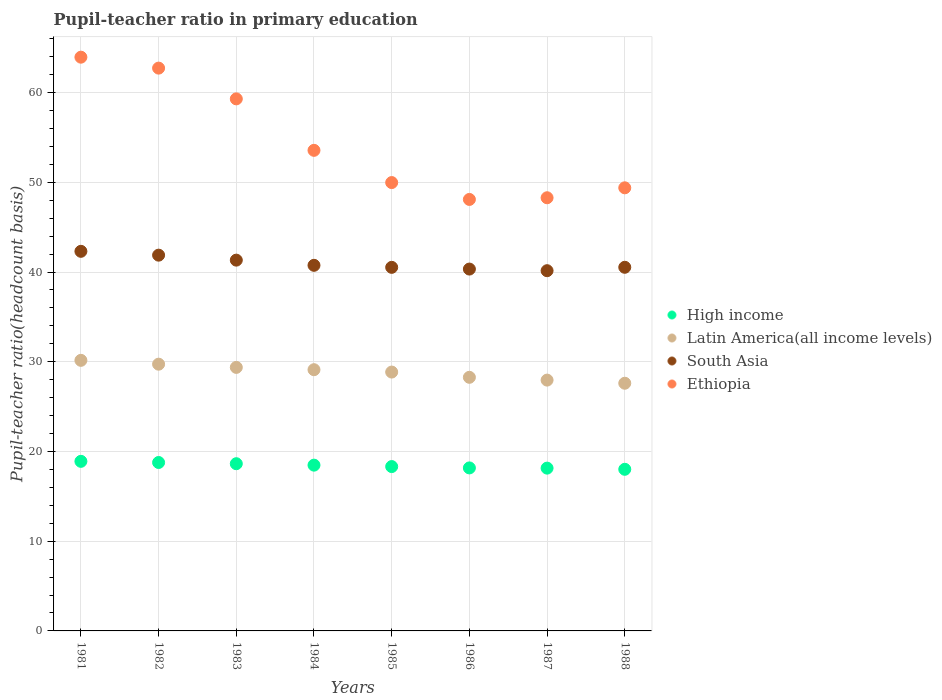How many different coloured dotlines are there?
Give a very brief answer. 4. Is the number of dotlines equal to the number of legend labels?
Your answer should be compact. Yes. What is the pupil-teacher ratio in primary education in Latin America(all income levels) in 1981?
Make the answer very short. 30.16. Across all years, what is the maximum pupil-teacher ratio in primary education in South Asia?
Offer a very short reply. 42.31. Across all years, what is the minimum pupil-teacher ratio in primary education in South Asia?
Make the answer very short. 40.15. In which year was the pupil-teacher ratio in primary education in High income minimum?
Offer a terse response. 1988. What is the total pupil-teacher ratio in primary education in High income in the graph?
Your answer should be compact. 147.42. What is the difference between the pupil-teacher ratio in primary education in South Asia in 1981 and that in 1985?
Provide a short and direct response. 1.79. What is the difference between the pupil-teacher ratio in primary education in South Asia in 1988 and the pupil-teacher ratio in primary education in Latin America(all income levels) in 1981?
Your answer should be very brief. 10.37. What is the average pupil-teacher ratio in primary education in Ethiopia per year?
Your answer should be very brief. 54.41. In the year 1987, what is the difference between the pupil-teacher ratio in primary education in Ethiopia and pupil-teacher ratio in primary education in South Asia?
Your response must be concise. 8.13. In how many years, is the pupil-teacher ratio in primary education in Ethiopia greater than 46?
Your answer should be very brief. 8. What is the ratio of the pupil-teacher ratio in primary education in South Asia in 1982 to that in 1987?
Make the answer very short. 1.04. Is the pupil-teacher ratio in primary education in Ethiopia in 1981 less than that in 1984?
Offer a very short reply. No. Is the difference between the pupil-teacher ratio in primary education in Ethiopia in 1982 and 1987 greater than the difference between the pupil-teacher ratio in primary education in South Asia in 1982 and 1987?
Your response must be concise. Yes. What is the difference between the highest and the second highest pupil-teacher ratio in primary education in Ethiopia?
Provide a succinct answer. 1.22. What is the difference between the highest and the lowest pupil-teacher ratio in primary education in High income?
Your answer should be compact. 0.89. Is the sum of the pupil-teacher ratio in primary education in South Asia in 1984 and 1988 greater than the maximum pupil-teacher ratio in primary education in Ethiopia across all years?
Offer a terse response. Yes. Is it the case that in every year, the sum of the pupil-teacher ratio in primary education in Latin America(all income levels) and pupil-teacher ratio in primary education in High income  is greater than the sum of pupil-teacher ratio in primary education in Ethiopia and pupil-teacher ratio in primary education in South Asia?
Your answer should be very brief. No. Does the pupil-teacher ratio in primary education in Latin America(all income levels) monotonically increase over the years?
Offer a terse response. No. How many dotlines are there?
Your answer should be compact. 4. Are the values on the major ticks of Y-axis written in scientific E-notation?
Your answer should be very brief. No. How are the legend labels stacked?
Keep it short and to the point. Vertical. What is the title of the graph?
Your answer should be compact. Pupil-teacher ratio in primary education. Does "Nepal" appear as one of the legend labels in the graph?
Your answer should be very brief. No. What is the label or title of the Y-axis?
Ensure brevity in your answer.  Pupil-teacher ratio(headcount basis). What is the Pupil-teacher ratio(headcount basis) of High income in 1981?
Offer a very short reply. 18.9. What is the Pupil-teacher ratio(headcount basis) in Latin America(all income levels) in 1981?
Provide a succinct answer. 30.16. What is the Pupil-teacher ratio(headcount basis) in South Asia in 1981?
Your response must be concise. 42.31. What is the Pupil-teacher ratio(headcount basis) in Ethiopia in 1981?
Give a very brief answer. 63.94. What is the Pupil-teacher ratio(headcount basis) of High income in 1982?
Offer a terse response. 18.77. What is the Pupil-teacher ratio(headcount basis) in Latin America(all income levels) in 1982?
Keep it short and to the point. 29.73. What is the Pupil-teacher ratio(headcount basis) in South Asia in 1982?
Give a very brief answer. 41.88. What is the Pupil-teacher ratio(headcount basis) in Ethiopia in 1982?
Keep it short and to the point. 62.72. What is the Pupil-teacher ratio(headcount basis) in High income in 1983?
Keep it short and to the point. 18.64. What is the Pupil-teacher ratio(headcount basis) in Latin America(all income levels) in 1983?
Offer a terse response. 29.37. What is the Pupil-teacher ratio(headcount basis) in South Asia in 1983?
Keep it short and to the point. 41.32. What is the Pupil-teacher ratio(headcount basis) of Ethiopia in 1983?
Your answer should be compact. 59.3. What is the Pupil-teacher ratio(headcount basis) in High income in 1984?
Offer a terse response. 18.48. What is the Pupil-teacher ratio(headcount basis) in Latin America(all income levels) in 1984?
Give a very brief answer. 29.11. What is the Pupil-teacher ratio(headcount basis) in South Asia in 1984?
Make the answer very short. 40.75. What is the Pupil-teacher ratio(headcount basis) in Ethiopia in 1984?
Make the answer very short. 53.56. What is the Pupil-teacher ratio(headcount basis) of High income in 1985?
Offer a very short reply. 18.32. What is the Pupil-teacher ratio(headcount basis) in Latin America(all income levels) in 1985?
Provide a short and direct response. 28.85. What is the Pupil-teacher ratio(headcount basis) in South Asia in 1985?
Give a very brief answer. 40.52. What is the Pupil-teacher ratio(headcount basis) of Ethiopia in 1985?
Give a very brief answer. 49.97. What is the Pupil-teacher ratio(headcount basis) in High income in 1986?
Your answer should be compact. 18.17. What is the Pupil-teacher ratio(headcount basis) in Latin America(all income levels) in 1986?
Provide a succinct answer. 28.26. What is the Pupil-teacher ratio(headcount basis) of South Asia in 1986?
Your response must be concise. 40.33. What is the Pupil-teacher ratio(headcount basis) of Ethiopia in 1986?
Give a very brief answer. 48.09. What is the Pupil-teacher ratio(headcount basis) of High income in 1987?
Your answer should be very brief. 18.14. What is the Pupil-teacher ratio(headcount basis) in Latin America(all income levels) in 1987?
Ensure brevity in your answer.  27.95. What is the Pupil-teacher ratio(headcount basis) in South Asia in 1987?
Offer a very short reply. 40.15. What is the Pupil-teacher ratio(headcount basis) in Ethiopia in 1987?
Keep it short and to the point. 48.28. What is the Pupil-teacher ratio(headcount basis) in High income in 1988?
Provide a succinct answer. 18.01. What is the Pupil-teacher ratio(headcount basis) of Latin America(all income levels) in 1988?
Your response must be concise. 27.6. What is the Pupil-teacher ratio(headcount basis) in South Asia in 1988?
Keep it short and to the point. 40.53. What is the Pupil-teacher ratio(headcount basis) of Ethiopia in 1988?
Make the answer very short. 49.38. Across all years, what is the maximum Pupil-teacher ratio(headcount basis) in High income?
Offer a very short reply. 18.9. Across all years, what is the maximum Pupil-teacher ratio(headcount basis) of Latin America(all income levels)?
Your answer should be compact. 30.16. Across all years, what is the maximum Pupil-teacher ratio(headcount basis) in South Asia?
Your answer should be very brief. 42.31. Across all years, what is the maximum Pupil-teacher ratio(headcount basis) in Ethiopia?
Keep it short and to the point. 63.94. Across all years, what is the minimum Pupil-teacher ratio(headcount basis) in High income?
Your answer should be very brief. 18.01. Across all years, what is the minimum Pupil-teacher ratio(headcount basis) of Latin America(all income levels)?
Your response must be concise. 27.6. Across all years, what is the minimum Pupil-teacher ratio(headcount basis) in South Asia?
Make the answer very short. 40.15. Across all years, what is the minimum Pupil-teacher ratio(headcount basis) in Ethiopia?
Provide a short and direct response. 48.09. What is the total Pupil-teacher ratio(headcount basis) in High income in the graph?
Offer a terse response. 147.42. What is the total Pupil-teacher ratio(headcount basis) in Latin America(all income levels) in the graph?
Ensure brevity in your answer.  231.04. What is the total Pupil-teacher ratio(headcount basis) in South Asia in the graph?
Offer a very short reply. 327.78. What is the total Pupil-teacher ratio(headcount basis) in Ethiopia in the graph?
Keep it short and to the point. 435.24. What is the difference between the Pupil-teacher ratio(headcount basis) in High income in 1981 and that in 1982?
Keep it short and to the point. 0.13. What is the difference between the Pupil-teacher ratio(headcount basis) in Latin America(all income levels) in 1981 and that in 1982?
Offer a very short reply. 0.43. What is the difference between the Pupil-teacher ratio(headcount basis) in South Asia in 1981 and that in 1982?
Give a very brief answer. 0.43. What is the difference between the Pupil-teacher ratio(headcount basis) of Ethiopia in 1981 and that in 1982?
Your answer should be very brief. 1.22. What is the difference between the Pupil-teacher ratio(headcount basis) of High income in 1981 and that in 1983?
Give a very brief answer. 0.26. What is the difference between the Pupil-teacher ratio(headcount basis) of Latin America(all income levels) in 1981 and that in 1983?
Offer a very short reply. 0.79. What is the difference between the Pupil-teacher ratio(headcount basis) in South Asia in 1981 and that in 1983?
Offer a terse response. 0.98. What is the difference between the Pupil-teacher ratio(headcount basis) in Ethiopia in 1981 and that in 1983?
Provide a succinct answer. 4.65. What is the difference between the Pupil-teacher ratio(headcount basis) of High income in 1981 and that in 1984?
Offer a very short reply. 0.42. What is the difference between the Pupil-teacher ratio(headcount basis) of Latin America(all income levels) in 1981 and that in 1984?
Provide a succinct answer. 1.04. What is the difference between the Pupil-teacher ratio(headcount basis) of South Asia in 1981 and that in 1984?
Provide a succinct answer. 1.56. What is the difference between the Pupil-teacher ratio(headcount basis) in Ethiopia in 1981 and that in 1984?
Your answer should be very brief. 10.38. What is the difference between the Pupil-teacher ratio(headcount basis) in High income in 1981 and that in 1985?
Make the answer very short. 0.58. What is the difference between the Pupil-teacher ratio(headcount basis) of Latin America(all income levels) in 1981 and that in 1985?
Your answer should be compact. 1.31. What is the difference between the Pupil-teacher ratio(headcount basis) of South Asia in 1981 and that in 1985?
Give a very brief answer. 1.79. What is the difference between the Pupil-teacher ratio(headcount basis) of Ethiopia in 1981 and that in 1985?
Offer a very short reply. 13.97. What is the difference between the Pupil-teacher ratio(headcount basis) in High income in 1981 and that in 1986?
Your response must be concise. 0.73. What is the difference between the Pupil-teacher ratio(headcount basis) of Latin America(all income levels) in 1981 and that in 1986?
Give a very brief answer. 1.89. What is the difference between the Pupil-teacher ratio(headcount basis) in South Asia in 1981 and that in 1986?
Provide a short and direct response. 1.98. What is the difference between the Pupil-teacher ratio(headcount basis) in Ethiopia in 1981 and that in 1986?
Keep it short and to the point. 15.85. What is the difference between the Pupil-teacher ratio(headcount basis) in High income in 1981 and that in 1987?
Provide a succinct answer. 0.76. What is the difference between the Pupil-teacher ratio(headcount basis) of Latin America(all income levels) in 1981 and that in 1987?
Your answer should be compact. 2.2. What is the difference between the Pupil-teacher ratio(headcount basis) of South Asia in 1981 and that in 1987?
Offer a terse response. 2.16. What is the difference between the Pupil-teacher ratio(headcount basis) in Ethiopia in 1981 and that in 1987?
Provide a short and direct response. 15.67. What is the difference between the Pupil-teacher ratio(headcount basis) of High income in 1981 and that in 1988?
Offer a terse response. 0.89. What is the difference between the Pupil-teacher ratio(headcount basis) in Latin America(all income levels) in 1981 and that in 1988?
Give a very brief answer. 2.55. What is the difference between the Pupil-teacher ratio(headcount basis) of South Asia in 1981 and that in 1988?
Your response must be concise. 1.78. What is the difference between the Pupil-teacher ratio(headcount basis) of Ethiopia in 1981 and that in 1988?
Your answer should be compact. 14.56. What is the difference between the Pupil-teacher ratio(headcount basis) of High income in 1982 and that in 1983?
Offer a very short reply. 0.13. What is the difference between the Pupil-teacher ratio(headcount basis) of Latin America(all income levels) in 1982 and that in 1983?
Make the answer very short. 0.36. What is the difference between the Pupil-teacher ratio(headcount basis) in South Asia in 1982 and that in 1983?
Give a very brief answer. 0.55. What is the difference between the Pupil-teacher ratio(headcount basis) in Ethiopia in 1982 and that in 1983?
Give a very brief answer. 3.43. What is the difference between the Pupil-teacher ratio(headcount basis) in High income in 1982 and that in 1984?
Provide a short and direct response. 0.3. What is the difference between the Pupil-teacher ratio(headcount basis) in Latin America(all income levels) in 1982 and that in 1984?
Offer a terse response. 0.61. What is the difference between the Pupil-teacher ratio(headcount basis) of South Asia in 1982 and that in 1984?
Provide a succinct answer. 1.13. What is the difference between the Pupil-teacher ratio(headcount basis) of Ethiopia in 1982 and that in 1984?
Offer a very short reply. 9.16. What is the difference between the Pupil-teacher ratio(headcount basis) in High income in 1982 and that in 1985?
Your answer should be very brief. 0.45. What is the difference between the Pupil-teacher ratio(headcount basis) in Latin America(all income levels) in 1982 and that in 1985?
Give a very brief answer. 0.88. What is the difference between the Pupil-teacher ratio(headcount basis) in South Asia in 1982 and that in 1985?
Your answer should be very brief. 1.36. What is the difference between the Pupil-teacher ratio(headcount basis) in Ethiopia in 1982 and that in 1985?
Offer a very short reply. 12.76. What is the difference between the Pupil-teacher ratio(headcount basis) in High income in 1982 and that in 1986?
Ensure brevity in your answer.  0.6. What is the difference between the Pupil-teacher ratio(headcount basis) of Latin America(all income levels) in 1982 and that in 1986?
Offer a terse response. 1.46. What is the difference between the Pupil-teacher ratio(headcount basis) in South Asia in 1982 and that in 1986?
Keep it short and to the point. 1.55. What is the difference between the Pupil-teacher ratio(headcount basis) of Ethiopia in 1982 and that in 1986?
Ensure brevity in your answer.  14.64. What is the difference between the Pupil-teacher ratio(headcount basis) of High income in 1982 and that in 1987?
Give a very brief answer. 0.63. What is the difference between the Pupil-teacher ratio(headcount basis) in Latin America(all income levels) in 1982 and that in 1987?
Ensure brevity in your answer.  1.78. What is the difference between the Pupil-teacher ratio(headcount basis) of South Asia in 1982 and that in 1987?
Give a very brief answer. 1.73. What is the difference between the Pupil-teacher ratio(headcount basis) of Ethiopia in 1982 and that in 1987?
Your answer should be very brief. 14.45. What is the difference between the Pupil-teacher ratio(headcount basis) of High income in 1982 and that in 1988?
Your response must be concise. 0.76. What is the difference between the Pupil-teacher ratio(headcount basis) of Latin America(all income levels) in 1982 and that in 1988?
Provide a short and direct response. 2.12. What is the difference between the Pupil-teacher ratio(headcount basis) of South Asia in 1982 and that in 1988?
Offer a terse response. 1.35. What is the difference between the Pupil-teacher ratio(headcount basis) in Ethiopia in 1982 and that in 1988?
Your response must be concise. 13.34. What is the difference between the Pupil-teacher ratio(headcount basis) of High income in 1983 and that in 1984?
Ensure brevity in your answer.  0.16. What is the difference between the Pupil-teacher ratio(headcount basis) of Latin America(all income levels) in 1983 and that in 1984?
Ensure brevity in your answer.  0.26. What is the difference between the Pupil-teacher ratio(headcount basis) in South Asia in 1983 and that in 1984?
Offer a very short reply. 0.58. What is the difference between the Pupil-teacher ratio(headcount basis) of Ethiopia in 1983 and that in 1984?
Your answer should be compact. 5.74. What is the difference between the Pupil-teacher ratio(headcount basis) of High income in 1983 and that in 1985?
Offer a very short reply. 0.32. What is the difference between the Pupil-teacher ratio(headcount basis) in Latin America(all income levels) in 1983 and that in 1985?
Your response must be concise. 0.52. What is the difference between the Pupil-teacher ratio(headcount basis) of South Asia in 1983 and that in 1985?
Provide a succinct answer. 0.8. What is the difference between the Pupil-teacher ratio(headcount basis) of Ethiopia in 1983 and that in 1985?
Your response must be concise. 9.33. What is the difference between the Pupil-teacher ratio(headcount basis) in High income in 1983 and that in 1986?
Offer a terse response. 0.47. What is the difference between the Pupil-teacher ratio(headcount basis) in Latin America(all income levels) in 1983 and that in 1986?
Keep it short and to the point. 1.11. What is the difference between the Pupil-teacher ratio(headcount basis) of Ethiopia in 1983 and that in 1986?
Keep it short and to the point. 11.21. What is the difference between the Pupil-teacher ratio(headcount basis) in High income in 1983 and that in 1987?
Your answer should be very brief. 0.49. What is the difference between the Pupil-teacher ratio(headcount basis) in Latin America(all income levels) in 1983 and that in 1987?
Provide a succinct answer. 1.42. What is the difference between the Pupil-teacher ratio(headcount basis) of South Asia in 1983 and that in 1987?
Provide a short and direct response. 1.18. What is the difference between the Pupil-teacher ratio(headcount basis) in Ethiopia in 1983 and that in 1987?
Keep it short and to the point. 11.02. What is the difference between the Pupil-teacher ratio(headcount basis) of High income in 1983 and that in 1988?
Your answer should be very brief. 0.62. What is the difference between the Pupil-teacher ratio(headcount basis) of Latin America(all income levels) in 1983 and that in 1988?
Ensure brevity in your answer.  1.77. What is the difference between the Pupil-teacher ratio(headcount basis) in South Asia in 1983 and that in 1988?
Offer a very short reply. 0.8. What is the difference between the Pupil-teacher ratio(headcount basis) in Ethiopia in 1983 and that in 1988?
Keep it short and to the point. 9.91. What is the difference between the Pupil-teacher ratio(headcount basis) in High income in 1984 and that in 1985?
Offer a very short reply. 0.16. What is the difference between the Pupil-teacher ratio(headcount basis) in Latin America(all income levels) in 1984 and that in 1985?
Make the answer very short. 0.26. What is the difference between the Pupil-teacher ratio(headcount basis) of South Asia in 1984 and that in 1985?
Keep it short and to the point. 0.23. What is the difference between the Pupil-teacher ratio(headcount basis) in Ethiopia in 1984 and that in 1985?
Give a very brief answer. 3.59. What is the difference between the Pupil-teacher ratio(headcount basis) of High income in 1984 and that in 1986?
Offer a very short reply. 0.31. What is the difference between the Pupil-teacher ratio(headcount basis) in Latin America(all income levels) in 1984 and that in 1986?
Offer a very short reply. 0.85. What is the difference between the Pupil-teacher ratio(headcount basis) in South Asia in 1984 and that in 1986?
Provide a short and direct response. 0.42. What is the difference between the Pupil-teacher ratio(headcount basis) of Ethiopia in 1984 and that in 1986?
Your answer should be very brief. 5.47. What is the difference between the Pupil-teacher ratio(headcount basis) of High income in 1984 and that in 1987?
Offer a very short reply. 0.33. What is the difference between the Pupil-teacher ratio(headcount basis) in Latin America(all income levels) in 1984 and that in 1987?
Provide a succinct answer. 1.16. What is the difference between the Pupil-teacher ratio(headcount basis) of South Asia in 1984 and that in 1987?
Your answer should be very brief. 0.6. What is the difference between the Pupil-teacher ratio(headcount basis) in Ethiopia in 1984 and that in 1987?
Your answer should be compact. 5.28. What is the difference between the Pupil-teacher ratio(headcount basis) of High income in 1984 and that in 1988?
Ensure brevity in your answer.  0.46. What is the difference between the Pupil-teacher ratio(headcount basis) of Latin America(all income levels) in 1984 and that in 1988?
Offer a very short reply. 1.51. What is the difference between the Pupil-teacher ratio(headcount basis) in South Asia in 1984 and that in 1988?
Your answer should be very brief. 0.22. What is the difference between the Pupil-teacher ratio(headcount basis) in Ethiopia in 1984 and that in 1988?
Ensure brevity in your answer.  4.18. What is the difference between the Pupil-teacher ratio(headcount basis) of High income in 1985 and that in 1986?
Keep it short and to the point. 0.15. What is the difference between the Pupil-teacher ratio(headcount basis) of Latin America(all income levels) in 1985 and that in 1986?
Your response must be concise. 0.58. What is the difference between the Pupil-teacher ratio(headcount basis) in South Asia in 1985 and that in 1986?
Your response must be concise. 0.19. What is the difference between the Pupil-teacher ratio(headcount basis) of Ethiopia in 1985 and that in 1986?
Your answer should be compact. 1.88. What is the difference between the Pupil-teacher ratio(headcount basis) in High income in 1985 and that in 1987?
Make the answer very short. 0.17. What is the difference between the Pupil-teacher ratio(headcount basis) of Latin America(all income levels) in 1985 and that in 1987?
Your answer should be very brief. 0.9. What is the difference between the Pupil-teacher ratio(headcount basis) of South Asia in 1985 and that in 1987?
Give a very brief answer. 0.37. What is the difference between the Pupil-teacher ratio(headcount basis) in Ethiopia in 1985 and that in 1987?
Make the answer very short. 1.69. What is the difference between the Pupil-teacher ratio(headcount basis) of High income in 1985 and that in 1988?
Give a very brief answer. 0.3. What is the difference between the Pupil-teacher ratio(headcount basis) in Latin America(all income levels) in 1985 and that in 1988?
Give a very brief answer. 1.25. What is the difference between the Pupil-teacher ratio(headcount basis) of South Asia in 1985 and that in 1988?
Give a very brief answer. -0.01. What is the difference between the Pupil-teacher ratio(headcount basis) in Ethiopia in 1985 and that in 1988?
Your response must be concise. 0.58. What is the difference between the Pupil-teacher ratio(headcount basis) of High income in 1986 and that in 1987?
Your response must be concise. 0.02. What is the difference between the Pupil-teacher ratio(headcount basis) in Latin America(all income levels) in 1986 and that in 1987?
Your response must be concise. 0.31. What is the difference between the Pupil-teacher ratio(headcount basis) of South Asia in 1986 and that in 1987?
Your answer should be compact. 0.18. What is the difference between the Pupil-teacher ratio(headcount basis) of Ethiopia in 1986 and that in 1987?
Give a very brief answer. -0.19. What is the difference between the Pupil-teacher ratio(headcount basis) of High income in 1986 and that in 1988?
Your answer should be compact. 0.15. What is the difference between the Pupil-teacher ratio(headcount basis) of Latin America(all income levels) in 1986 and that in 1988?
Give a very brief answer. 0.66. What is the difference between the Pupil-teacher ratio(headcount basis) in South Asia in 1986 and that in 1988?
Your response must be concise. -0.2. What is the difference between the Pupil-teacher ratio(headcount basis) of Ethiopia in 1986 and that in 1988?
Give a very brief answer. -1.3. What is the difference between the Pupil-teacher ratio(headcount basis) in High income in 1987 and that in 1988?
Give a very brief answer. 0.13. What is the difference between the Pupil-teacher ratio(headcount basis) in Latin America(all income levels) in 1987 and that in 1988?
Your answer should be very brief. 0.35. What is the difference between the Pupil-teacher ratio(headcount basis) of South Asia in 1987 and that in 1988?
Offer a very short reply. -0.38. What is the difference between the Pupil-teacher ratio(headcount basis) in Ethiopia in 1987 and that in 1988?
Keep it short and to the point. -1.11. What is the difference between the Pupil-teacher ratio(headcount basis) of High income in 1981 and the Pupil-teacher ratio(headcount basis) of Latin America(all income levels) in 1982?
Ensure brevity in your answer.  -10.83. What is the difference between the Pupil-teacher ratio(headcount basis) of High income in 1981 and the Pupil-teacher ratio(headcount basis) of South Asia in 1982?
Offer a very short reply. -22.98. What is the difference between the Pupil-teacher ratio(headcount basis) in High income in 1981 and the Pupil-teacher ratio(headcount basis) in Ethiopia in 1982?
Ensure brevity in your answer.  -43.82. What is the difference between the Pupil-teacher ratio(headcount basis) in Latin America(all income levels) in 1981 and the Pupil-teacher ratio(headcount basis) in South Asia in 1982?
Keep it short and to the point. -11.72. What is the difference between the Pupil-teacher ratio(headcount basis) of Latin America(all income levels) in 1981 and the Pupil-teacher ratio(headcount basis) of Ethiopia in 1982?
Offer a terse response. -32.57. What is the difference between the Pupil-teacher ratio(headcount basis) in South Asia in 1981 and the Pupil-teacher ratio(headcount basis) in Ethiopia in 1982?
Your answer should be compact. -20.42. What is the difference between the Pupil-teacher ratio(headcount basis) of High income in 1981 and the Pupil-teacher ratio(headcount basis) of Latin America(all income levels) in 1983?
Provide a short and direct response. -10.47. What is the difference between the Pupil-teacher ratio(headcount basis) of High income in 1981 and the Pupil-teacher ratio(headcount basis) of South Asia in 1983?
Your response must be concise. -22.42. What is the difference between the Pupil-teacher ratio(headcount basis) in High income in 1981 and the Pupil-teacher ratio(headcount basis) in Ethiopia in 1983?
Give a very brief answer. -40.4. What is the difference between the Pupil-teacher ratio(headcount basis) of Latin America(all income levels) in 1981 and the Pupil-teacher ratio(headcount basis) of South Asia in 1983?
Your answer should be very brief. -11.17. What is the difference between the Pupil-teacher ratio(headcount basis) in Latin America(all income levels) in 1981 and the Pupil-teacher ratio(headcount basis) in Ethiopia in 1983?
Offer a terse response. -29.14. What is the difference between the Pupil-teacher ratio(headcount basis) in South Asia in 1981 and the Pupil-teacher ratio(headcount basis) in Ethiopia in 1983?
Offer a terse response. -16.99. What is the difference between the Pupil-teacher ratio(headcount basis) of High income in 1981 and the Pupil-teacher ratio(headcount basis) of Latin America(all income levels) in 1984?
Provide a succinct answer. -10.21. What is the difference between the Pupil-teacher ratio(headcount basis) in High income in 1981 and the Pupil-teacher ratio(headcount basis) in South Asia in 1984?
Ensure brevity in your answer.  -21.85. What is the difference between the Pupil-teacher ratio(headcount basis) of High income in 1981 and the Pupil-teacher ratio(headcount basis) of Ethiopia in 1984?
Your answer should be very brief. -34.66. What is the difference between the Pupil-teacher ratio(headcount basis) in Latin America(all income levels) in 1981 and the Pupil-teacher ratio(headcount basis) in South Asia in 1984?
Ensure brevity in your answer.  -10.59. What is the difference between the Pupil-teacher ratio(headcount basis) in Latin America(all income levels) in 1981 and the Pupil-teacher ratio(headcount basis) in Ethiopia in 1984?
Your response must be concise. -23.41. What is the difference between the Pupil-teacher ratio(headcount basis) of South Asia in 1981 and the Pupil-teacher ratio(headcount basis) of Ethiopia in 1984?
Your response must be concise. -11.26. What is the difference between the Pupil-teacher ratio(headcount basis) in High income in 1981 and the Pupil-teacher ratio(headcount basis) in Latin America(all income levels) in 1985?
Offer a very short reply. -9.95. What is the difference between the Pupil-teacher ratio(headcount basis) in High income in 1981 and the Pupil-teacher ratio(headcount basis) in South Asia in 1985?
Offer a very short reply. -21.62. What is the difference between the Pupil-teacher ratio(headcount basis) in High income in 1981 and the Pupil-teacher ratio(headcount basis) in Ethiopia in 1985?
Give a very brief answer. -31.07. What is the difference between the Pupil-teacher ratio(headcount basis) in Latin America(all income levels) in 1981 and the Pupil-teacher ratio(headcount basis) in South Asia in 1985?
Your answer should be compact. -10.36. What is the difference between the Pupil-teacher ratio(headcount basis) of Latin America(all income levels) in 1981 and the Pupil-teacher ratio(headcount basis) of Ethiopia in 1985?
Provide a succinct answer. -19.81. What is the difference between the Pupil-teacher ratio(headcount basis) of South Asia in 1981 and the Pupil-teacher ratio(headcount basis) of Ethiopia in 1985?
Ensure brevity in your answer.  -7.66. What is the difference between the Pupil-teacher ratio(headcount basis) in High income in 1981 and the Pupil-teacher ratio(headcount basis) in Latin America(all income levels) in 1986?
Your response must be concise. -9.36. What is the difference between the Pupil-teacher ratio(headcount basis) in High income in 1981 and the Pupil-teacher ratio(headcount basis) in South Asia in 1986?
Give a very brief answer. -21.43. What is the difference between the Pupil-teacher ratio(headcount basis) of High income in 1981 and the Pupil-teacher ratio(headcount basis) of Ethiopia in 1986?
Provide a succinct answer. -29.19. What is the difference between the Pupil-teacher ratio(headcount basis) in Latin America(all income levels) in 1981 and the Pupil-teacher ratio(headcount basis) in South Asia in 1986?
Make the answer very short. -10.17. What is the difference between the Pupil-teacher ratio(headcount basis) of Latin America(all income levels) in 1981 and the Pupil-teacher ratio(headcount basis) of Ethiopia in 1986?
Your answer should be compact. -17.93. What is the difference between the Pupil-teacher ratio(headcount basis) of South Asia in 1981 and the Pupil-teacher ratio(headcount basis) of Ethiopia in 1986?
Your answer should be compact. -5.78. What is the difference between the Pupil-teacher ratio(headcount basis) of High income in 1981 and the Pupil-teacher ratio(headcount basis) of Latin America(all income levels) in 1987?
Offer a very short reply. -9.05. What is the difference between the Pupil-teacher ratio(headcount basis) of High income in 1981 and the Pupil-teacher ratio(headcount basis) of South Asia in 1987?
Ensure brevity in your answer.  -21.25. What is the difference between the Pupil-teacher ratio(headcount basis) of High income in 1981 and the Pupil-teacher ratio(headcount basis) of Ethiopia in 1987?
Your answer should be very brief. -29.38. What is the difference between the Pupil-teacher ratio(headcount basis) of Latin America(all income levels) in 1981 and the Pupil-teacher ratio(headcount basis) of South Asia in 1987?
Keep it short and to the point. -9.99. What is the difference between the Pupil-teacher ratio(headcount basis) of Latin America(all income levels) in 1981 and the Pupil-teacher ratio(headcount basis) of Ethiopia in 1987?
Ensure brevity in your answer.  -18.12. What is the difference between the Pupil-teacher ratio(headcount basis) in South Asia in 1981 and the Pupil-teacher ratio(headcount basis) in Ethiopia in 1987?
Your answer should be compact. -5.97. What is the difference between the Pupil-teacher ratio(headcount basis) of High income in 1981 and the Pupil-teacher ratio(headcount basis) of Latin America(all income levels) in 1988?
Your response must be concise. -8.7. What is the difference between the Pupil-teacher ratio(headcount basis) in High income in 1981 and the Pupil-teacher ratio(headcount basis) in South Asia in 1988?
Offer a terse response. -21.63. What is the difference between the Pupil-teacher ratio(headcount basis) in High income in 1981 and the Pupil-teacher ratio(headcount basis) in Ethiopia in 1988?
Provide a succinct answer. -30.48. What is the difference between the Pupil-teacher ratio(headcount basis) of Latin America(all income levels) in 1981 and the Pupil-teacher ratio(headcount basis) of South Asia in 1988?
Provide a short and direct response. -10.37. What is the difference between the Pupil-teacher ratio(headcount basis) in Latin America(all income levels) in 1981 and the Pupil-teacher ratio(headcount basis) in Ethiopia in 1988?
Provide a short and direct response. -19.23. What is the difference between the Pupil-teacher ratio(headcount basis) in South Asia in 1981 and the Pupil-teacher ratio(headcount basis) in Ethiopia in 1988?
Keep it short and to the point. -7.08. What is the difference between the Pupil-teacher ratio(headcount basis) in High income in 1982 and the Pupil-teacher ratio(headcount basis) in Latin America(all income levels) in 1983?
Offer a very short reply. -10.6. What is the difference between the Pupil-teacher ratio(headcount basis) in High income in 1982 and the Pupil-teacher ratio(headcount basis) in South Asia in 1983?
Offer a terse response. -22.55. What is the difference between the Pupil-teacher ratio(headcount basis) of High income in 1982 and the Pupil-teacher ratio(headcount basis) of Ethiopia in 1983?
Give a very brief answer. -40.53. What is the difference between the Pupil-teacher ratio(headcount basis) of Latin America(all income levels) in 1982 and the Pupil-teacher ratio(headcount basis) of South Asia in 1983?
Your response must be concise. -11.6. What is the difference between the Pupil-teacher ratio(headcount basis) in Latin America(all income levels) in 1982 and the Pupil-teacher ratio(headcount basis) in Ethiopia in 1983?
Provide a succinct answer. -29.57. What is the difference between the Pupil-teacher ratio(headcount basis) of South Asia in 1982 and the Pupil-teacher ratio(headcount basis) of Ethiopia in 1983?
Make the answer very short. -17.42. What is the difference between the Pupil-teacher ratio(headcount basis) of High income in 1982 and the Pupil-teacher ratio(headcount basis) of Latin America(all income levels) in 1984?
Your answer should be very brief. -10.34. What is the difference between the Pupil-teacher ratio(headcount basis) in High income in 1982 and the Pupil-teacher ratio(headcount basis) in South Asia in 1984?
Offer a terse response. -21.97. What is the difference between the Pupil-teacher ratio(headcount basis) in High income in 1982 and the Pupil-teacher ratio(headcount basis) in Ethiopia in 1984?
Provide a short and direct response. -34.79. What is the difference between the Pupil-teacher ratio(headcount basis) in Latin America(all income levels) in 1982 and the Pupil-teacher ratio(headcount basis) in South Asia in 1984?
Provide a succinct answer. -11.02. What is the difference between the Pupil-teacher ratio(headcount basis) of Latin America(all income levels) in 1982 and the Pupil-teacher ratio(headcount basis) of Ethiopia in 1984?
Provide a succinct answer. -23.83. What is the difference between the Pupil-teacher ratio(headcount basis) in South Asia in 1982 and the Pupil-teacher ratio(headcount basis) in Ethiopia in 1984?
Provide a succinct answer. -11.68. What is the difference between the Pupil-teacher ratio(headcount basis) of High income in 1982 and the Pupil-teacher ratio(headcount basis) of Latin America(all income levels) in 1985?
Offer a terse response. -10.08. What is the difference between the Pupil-teacher ratio(headcount basis) in High income in 1982 and the Pupil-teacher ratio(headcount basis) in South Asia in 1985?
Your answer should be very brief. -21.75. What is the difference between the Pupil-teacher ratio(headcount basis) in High income in 1982 and the Pupil-teacher ratio(headcount basis) in Ethiopia in 1985?
Make the answer very short. -31.2. What is the difference between the Pupil-teacher ratio(headcount basis) in Latin America(all income levels) in 1982 and the Pupil-teacher ratio(headcount basis) in South Asia in 1985?
Provide a short and direct response. -10.79. What is the difference between the Pupil-teacher ratio(headcount basis) of Latin America(all income levels) in 1982 and the Pupil-teacher ratio(headcount basis) of Ethiopia in 1985?
Ensure brevity in your answer.  -20.24. What is the difference between the Pupil-teacher ratio(headcount basis) of South Asia in 1982 and the Pupil-teacher ratio(headcount basis) of Ethiopia in 1985?
Your answer should be compact. -8.09. What is the difference between the Pupil-teacher ratio(headcount basis) in High income in 1982 and the Pupil-teacher ratio(headcount basis) in Latin America(all income levels) in 1986?
Your answer should be compact. -9.49. What is the difference between the Pupil-teacher ratio(headcount basis) of High income in 1982 and the Pupil-teacher ratio(headcount basis) of South Asia in 1986?
Offer a very short reply. -21.56. What is the difference between the Pupil-teacher ratio(headcount basis) in High income in 1982 and the Pupil-teacher ratio(headcount basis) in Ethiopia in 1986?
Provide a succinct answer. -29.32. What is the difference between the Pupil-teacher ratio(headcount basis) in Latin America(all income levels) in 1982 and the Pupil-teacher ratio(headcount basis) in South Asia in 1986?
Offer a terse response. -10.6. What is the difference between the Pupil-teacher ratio(headcount basis) of Latin America(all income levels) in 1982 and the Pupil-teacher ratio(headcount basis) of Ethiopia in 1986?
Provide a succinct answer. -18.36. What is the difference between the Pupil-teacher ratio(headcount basis) in South Asia in 1982 and the Pupil-teacher ratio(headcount basis) in Ethiopia in 1986?
Your response must be concise. -6.21. What is the difference between the Pupil-teacher ratio(headcount basis) in High income in 1982 and the Pupil-teacher ratio(headcount basis) in Latin America(all income levels) in 1987?
Provide a short and direct response. -9.18. What is the difference between the Pupil-teacher ratio(headcount basis) in High income in 1982 and the Pupil-teacher ratio(headcount basis) in South Asia in 1987?
Your answer should be compact. -21.38. What is the difference between the Pupil-teacher ratio(headcount basis) of High income in 1982 and the Pupil-teacher ratio(headcount basis) of Ethiopia in 1987?
Give a very brief answer. -29.51. What is the difference between the Pupil-teacher ratio(headcount basis) of Latin America(all income levels) in 1982 and the Pupil-teacher ratio(headcount basis) of South Asia in 1987?
Keep it short and to the point. -10.42. What is the difference between the Pupil-teacher ratio(headcount basis) in Latin America(all income levels) in 1982 and the Pupil-teacher ratio(headcount basis) in Ethiopia in 1987?
Keep it short and to the point. -18.55. What is the difference between the Pupil-teacher ratio(headcount basis) of South Asia in 1982 and the Pupil-teacher ratio(headcount basis) of Ethiopia in 1987?
Your answer should be compact. -6.4. What is the difference between the Pupil-teacher ratio(headcount basis) of High income in 1982 and the Pupil-teacher ratio(headcount basis) of Latin America(all income levels) in 1988?
Your answer should be very brief. -8.83. What is the difference between the Pupil-teacher ratio(headcount basis) in High income in 1982 and the Pupil-teacher ratio(headcount basis) in South Asia in 1988?
Your response must be concise. -21.76. What is the difference between the Pupil-teacher ratio(headcount basis) in High income in 1982 and the Pupil-teacher ratio(headcount basis) in Ethiopia in 1988?
Ensure brevity in your answer.  -30.61. What is the difference between the Pupil-teacher ratio(headcount basis) in Latin America(all income levels) in 1982 and the Pupil-teacher ratio(headcount basis) in South Asia in 1988?
Make the answer very short. -10.8. What is the difference between the Pupil-teacher ratio(headcount basis) in Latin America(all income levels) in 1982 and the Pupil-teacher ratio(headcount basis) in Ethiopia in 1988?
Provide a succinct answer. -19.66. What is the difference between the Pupil-teacher ratio(headcount basis) in South Asia in 1982 and the Pupil-teacher ratio(headcount basis) in Ethiopia in 1988?
Provide a succinct answer. -7.51. What is the difference between the Pupil-teacher ratio(headcount basis) in High income in 1983 and the Pupil-teacher ratio(headcount basis) in Latin America(all income levels) in 1984?
Offer a very short reply. -10.48. What is the difference between the Pupil-teacher ratio(headcount basis) in High income in 1983 and the Pupil-teacher ratio(headcount basis) in South Asia in 1984?
Offer a terse response. -22.11. What is the difference between the Pupil-teacher ratio(headcount basis) in High income in 1983 and the Pupil-teacher ratio(headcount basis) in Ethiopia in 1984?
Provide a succinct answer. -34.92. What is the difference between the Pupil-teacher ratio(headcount basis) in Latin America(all income levels) in 1983 and the Pupil-teacher ratio(headcount basis) in South Asia in 1984?
Offer a very short reply. -11.38. What is the difference between the Pupil-teacher ratio(headcount basis) in Latin America(all income levels) in 1983 and the Pupil-teacher ratio(headcount basis) in Ethiopia in 1984?
Your answer should be compact. -24.19. What is the difference between the Pupil-teacher ratio(headcount basis) in South Asia in 1983 and the Pupil-teacher ratio(headcount basis) in Ethiopia in 1984?
Make the answer very short. -12.24. What is the difference between the Pupil-teacher ratio(headcount basis) in High income in 1983 and the Pupil-teacher ratio(headcount basis) in Latin America(all income levels) in 1985?
Your answer should be very brief. -10.21. What is the difference between the Pupil-teacher ratio(headcount basis) in High income in 1983 and the Pupil-teacher ratio(headcount basis) in South Asia in 1985?
Offer a very short reply. -21.88. What is the difference between the Pupil-teacher ratio(headcount basis) in High income in 1983 and the Pupil-teacher ratio(headcount basis) in Ethiopia in 1985?
Make the answer very short. -31.33. What is the difference between the Pupil-teacher ratio(headcount basis) in Latin America(all income levels) in 1983 and the Pupil-teacher ratio(headcount basis) in South Asia in 1985?
Give a very brief answer. -11.15. What is the difference between the Pupil-teacher ratio(headcount basis) of Latin America(all income levels) in 1983 and the Pupil-teacher ratio(headcount basis) of Ethiopia in 1985?
Ensure brevity in your answer.  -20.6. What is the difference between the Pupil-teacher ratio(headcount basis) of South Asia in 1983 and the Pupil-teacher ratio(headcount basis) of Ethiopia in 1985?
Provide a short and direct response. -8.64. What is the difference between the Pupil-teacher ratio(headcount basis) in High income in 1983 and the Pupil-teacher ratio(headcount basis) in Latin America(all income levels) in 1986?
Give a very brief answer. -9.63. What is the difference between the Pupil-teacher ratio(headcount basis) in High income in 1983 and the Pupil-teacher ratio(headcount basis) in South Asia in 1986?
Keep it short and to the point. -21.69. What is the difference between the Pupil-teacher ratio(headcount basis) in High income in 1983 and the Pupil-teacher ratio(headcount basis) in Ethiopia in 1986?
Provide a succinct answer. -29.45. What is the difference between the Pupil-teacher ratio(headcount basis) of Latin America(all income levels) in 1983 and the Pupil-teacher ratio(headcount basis) of South Asia in 1986?
Offer a very short reply. -10.96. What is the difference between the Pupil-teacher ratio(headcount basis) in Latin America(all income levels) in 1983 and the Pupil-teacher ratio(headcount basis) in Ethiopia in 1986?
Ensure brevity in your answer.  -18.72. What is the difference between the Pupil-teacher ratio(headcount basis) of South Asia in 1983 and the Pupil-teacher ratio(headcount basis) of Ethiopia in 1986?
Make the answer very short. -6.77. What is the difference between the Pupil-teacher ratio(headcount basis) in High income in 1983 and the Pupil-teacher ratio(headcount basis) in Latin America(all income levels) in 1987?
Your answer should be very brief. -9.32. What is the difference between the Pupil-teacher ratio(headcount basis) of High income in 1983 and the Pupil-teacher ratio(headcount basis) of South Asia in 1987?
Give a very brief answer. -21.51. What is the difference between the Pupil-teacher ratio(headcount basis) in High income in 1983 and the Pupil-teacher ratio(headcount basis) in Ethiopia in 1987?
Give a very brief answer. -29.64. What is the difference between the Pupil-teacher ratio(headcount basis) in Latin America(all income levels) in 1983 and the Pupil-teacher ratio(headcount basis) in South Asia in 1987?
Make the answer very short. -10.78. What is the difference between the Pupil-teacher ratio(headcount basis) in Latin America(all income levels) in 1983 and the Pupil-teacher ratio(headcount basis) in Ethiopia in 1987?
Ensure brevity in your answer.  -18.91. What is the difference between the Pupil-teacher ratio(headcount basis) of South Asia in 1983 and the Pupil-teacher ratio(headcount basis) of Ethiopia in 1987?
Your answer should be compact. -6.95. What is the difference between the Pupil-teacher ratio(headcount basis) of High income in 1983 and the Pupil-teacher ratio(headcount basis) of Latin America(all income levels) in 1988?
Give a very brief answer. -8.97. What is the difference between the Pupil-teacher ratio(headcount basis) of High income in 1983 and the Pupil-teacher ratio(headcount basis) of South Asia in 1988?
Provide a succinct answer. -21.89. What is the difference between the Pupil-teacher ratio(headcount basis) in High income in 1983 and the Pupil-teacher ratio(headcount basis) in Ethiopia in 1988?
Give a very brief answer. -30.75. What is the difference between the Pupil-teacher ratio(headcount basis) of Latin America(all income levels) in 1983 and the Pupil-teacher ratio(headcount basis) of South Asia in 1988?
Make the answer very short. -11.16. What is the difference between the Pupil-teacher ratio(headcount basis) in Latin America(all income levels) in 1983 and the Pupil-teacher ratio(headcount basis) in Ethiopia in 1988?
Ensure brevity in your answer.  -20.01. What is the difference between the Pupil-teacher ratio(headcount basis) of South Asia in 1983 and the Pupil-teacher ratio(headcount basis) of Ethiopia in 1988?
Your answer should be very brief. -8.06. What is the difference between the Pupil-teacher ratio(headcount basis) in High income in 1984 and the Pupil-teacher ratio(headcount basis) in Latin America(all income levels) in 1985?
Provide a short and direct response. -10.37. What is the difference between the Pupil-teacher ratio(headcount basis) in High income in 1984 and the Pupil-teacher ratio(headcount basis) in South Asia in 1985?
Your answer should be very brief. -22.04. What is the difference between the Pupil-teacher ratio(headcount basis) of High income in 1984 and the Pupil-teacher ratio(headcount basis) of Ethiopia in 1985?
Ensure brevity in your answer.  -31.49. What is the difference between the Pupil-teacher ratio(headcount basis) in Latin America(all income levels) in 1984 and the Pupil-teacher ratio(headcount basis) in South Asia in 1985?
Provide a succinct answer. -11.41. What is the difference between the Pupil-teacher ratio(headcount basis) in Latin America(all income levels) in 1984 and the Pupil-teacher ratio(headcount basis) in Ethiopia in 1985?
Your answer should be very brief. -20.85. What is the difference between the Pupil-teacher ratio(headcount basis) in South Asia in 1984 and the Pupil-teacher ratio(headcount basis) in Ethiopia in 1985?
Your answer should be very brief. -9.22. What is the difference between the Pupil-teacher ratio(headcount basis) in High income in 1984 and the Pupil-teacher ratio(headcount basis) in Latin America(all income levels) in 1986?
Make the answer very short. -9.79. What is the difference between the Pupil-teacher ratio(headcount basis) of High income in 1984 and the Pupil-teacher ratio(headcount basis) of South Asia in 1986?
Make the answer very short. -21.85. What is the difference between the Pupil-teacher ratio(headcount basis) of High income in 1984 and the Pupil-teacher ratio(headcount basis) of Ethiopia in 1986?
Offer a very short reply. -29.61. What is the difference between the Pupil-teacher ratio(headcount basis) of Latin America(all income levels) in 1984 and the Pupil-teacher ratio(headcount basis) of South Asia in 1986?
Keep it short and to the point. -11.22. What is the difference between the Pupil-teacher ratio(headcount basis) of Latin America(all income levels) in 1984 and the Pupil-teacher ratio(headcount basis) of Ethiopia in 1986?
Ensure brevity in your answer.  -18.98. What is the difference between the Pupil-teacher ratio(headcount basis) in South Asia in 1984 and the Pupil-teacher ratio(headcount basis) in Ethiopia in 1986?
Keep it short and to the point. -7.34. What is the difference between the Pupil-teacher ratio(headcount basis) in High income in 1984 and the Pupil-teacher ratio(headcount basis) in Latin America(all income levels) in 1987?
Keep it short and to the point. -9.48. What is the difference between the Pupil-teacher ratio(headcount basis) of High income in 1984 and the Pupil-teacher ratio(headcount basis) of South Asia in 1987?
Your answer should be very brief. -21.67. What is the difference between the Pupil-teacher ratio(headcount basis) of High income in 1984 and the Pupil-teacher ratio(headcount basis) of Ethiopia in 1987?
Make the answer very short. -29.8. What is the difference between the Pupil-teacher ratio(headcount basis) in Latin America(all income levels) in 1984 and the Pupil-teacher ratio(headcount basis) in South Asia in 1987?
Ensure brevity in your answer.  -11.03. What is the difference between the Pupil-teacher ratio(headcount basis) in Latin America(all income levels) in 1984 and the Pupil-teacher ratio(headcount basis) in Ethiopia in 1987?
Your answer should be compact. -19.16. What is the difference between the Pupil-teacher ratio(headcount basis) of South Asia in 1984 and the Pupil-teacher ratio(headcount basis) of Ethiopia in 1987?
Your answer should be compact. -7.53. What is the difference between the Pupil-teacher ratio(headcount basis) in High income in 1984 and the Pupil-teacher ratio(headcount basis) in Latin America(all income levels) in 1988?
Ensure brevity in your answer.  -9.13. What is the difference between the Pupil-teacher ratio(headcount basis) in High income in 1984 and the Pupil-teacher ratio(headcount basis) in South Asia in 1988?
Give a very brief answer. -22.05. What is the difference between the Pupil-teacher ratio(headcount basis) of High income in 1984 and the Pupil-teacher ratio(headcount basis) of Ethiopia in 1988?
Ensure brevity in your answer.  -30.91. What is the difference between the Pupil-teacher ratio(headcount basis) of Latin America(all income levels) in 1984 and the Pupil-teacher ratio(headcount basis) of South Asia in 1988?
Your answer should be compact. -11.41. What is the difference between the Pupil-teacher ratio(headcount basis) of Latin America(all income levels) in 1984 and the Pupil-teacher ratio(headcount basis) of Ethiopia in 1988?
Your response must be concise. -20.27. What is the difference between the Pupil-teacher ratio(headcount basis) of South Asia in 1984 and the Pupil-teacher ratio(headcount basis) of Ethiopia in 1988?
Ensure brevity in your answer.  -8.64. What is the difference between the Pupil-teacher ratio(headcount basis) of High income in 1985 and the Pupil-teacher ratio(headcount basis) of Latin America(all income levels) in 1986?
Ensure brevity in your answer.  -9.95. What is the difference between the Pupil-teacher ratio(headcount basis) of High income in 1985 and the Pupil-teacher ratio(headcount basis) of South Asia in 1986?
Provide a succinct answer. -22.01. What is the difference between the Pupil-teacher ratio(headcount basis) of High income in 1985 and the Pupil-teacher ratio(headcount basis) of Ethiopia in 1986?
Give a very brief answer. -29.77. What is the difference between the Pupil-teacher ratio(headcount basis) in Latin America(all income levels) in 1985 and the Pupil-teacher ratio(headcount basis) in South Asia in 1986?
Keep it short and to the point. -11.48. What is the difference between the Pupil-teacher ratio(headcount basis) in Latin America(all income levels) in 1985 and the Pupil-teacher ratio(headcount basis) in Ethiopia in 1986?
Keep it short and to the point. -19.24. What is the difference between the Pupil-teacher ratio(headcount basis) in South Asia in 1985 and the Pupil-teacher ratio(headcount basis) in Ethiopia in 1986?
Your response must be concise. -7.57. What is the difference between the Pupil-teacher ratio(headcount basis) in High income in 1985 and the Pupil-teacher ratio(headcount basis) in Latin America(all income levels) in 1987?
Provide a succinct answer. -9.64. What is the difference between the Pupil-teacher ratio(headcount basis) in High income in 1985 and the Pupil-teacher ratio(headcount basis) in South Asia in 1987?
Make the answer very short. -21.83. What is the difference between the Pupil-teacher ratio(headcount basis) in High income in 1985 and the Pupil-teacher ratio(headcount basis) in Ethiopia in 1987?
Give a very brief answer. -29.96. What is the difference between the Pupil-teacher ratio(headcount basis) in Latin America(all income levels) in 1985 and the Pupil-teacher ratio(headcount basis) in South Asia in 1987?
Offer a terse response. -11.3. What is the difference between the Pupil-teacher ratio(headcount basis) in Latin America(all income levels) in 1985 and the Pupil-teacher ratio(headcount basis) in Ethiopia in 1987?
Keep it short and to the point. -19.43. What is the difference between the Pupil-teacher ratio(headcount basis) in South Asia in 1985 and the Pupil-teacher ratio(headcount basis) in Ethiopia in 1987?
Make the answer very short. -7.76. What is the difference between the Pupil-teacher ratio(headcount basis) of High income in 1985 and the Pupil-teacher ratio(headcount basis) of Latin America(all income levels) in 1988?
Provide a short and direct response. -9.29. What is the difference between the Pupil-teacher ratio(headcount basis) in High income in 1985 and the Pupil-teacher ratio(headcount basis) in South Asia in 1988?
Offer a very short reply. -22.21. What is the difference between the Pupil-teacher ratio(headcount basis) in High income in 1985 and the Pupil-teacher ratio(headcount basis) in Ethiopia in 1988?
Give a very brief answer. -31.07. What is the difference between the Pupil-teacher ratio(headcount basis) in Latin America(all income levels) in 1985 and the Pupil-teacher ratio(headcount basis) in South Asia in 1988?
Keep it short and to the point. -11.68. What is the difference between the Pupil-teacher ratio(headcount basis) in Latin America(all income levels) in 1985 and the Pupil-teacher ratio(headcount basis) in Ethiopia in 1988?
Keep it short and to the point. -20.53. What is the difference between the Pupil-teacher ratio(headcount basis) of South Asia in 1985 and the Pupil-teacher ratio(headcount basis) of Ethiopia in 1988?
Keep it short and to the point. -8.86. What is the difference between the Pupil-teacher ratio(headcount basis) in High income in 1986 and the Pupil-teacher ratio(headcount basis) in Latin America(all income levels) in 1987?
Ensure brevity in your answer.  -9.79. What is the difference between the Pupil-teacher ratio(headcount basis) of High income in 1986 and the Pupil-teacher ratio(headcount basis) of South Asia in 1987?
Your answer should be very brief. -21.98. What is the difference between the Pupil-teacher ratio(headcount basis) in High income in 1986 and the Pupil-teacher ratio(headcount basis) in Ethiopia in 1987?
Provide a succinct answer. -30.11. What is the difference between the Pupil-teacher ratio(headcount basis) of Latin America(all income levels) in 1986 and the Pupil-teacher ratio(headcount basis) of South Asia in 1987?
Provide a succinct answer. -11.88. What is the difference between the Pupil-teacher ratio(headcount basis) of Latin America(all income levels) in 1986 and the Pupil-teacher ratio(headcount basis) of Ethiopia in 1987?
Provide a succinct answer. -20.01. What is the difference between the Pupil-teacher ratio(headcount basis) of South Asia in 1986 and the Pupil-teacher ratio(headcount basis) of Ethiopia in 1987?
Provide a succinct answer. -7.95. What is the difference between the Pupil-teacher ratio(headcount basis) of High income in 1986 and the Pupil-teacher ratio(headcount basis) of Latin America(all income levels) in 1988?
Ensure brevity in your answer.  -9.44. What is the difference between the Pupil-teacher ratio(headcount basis) of High income in 1986 and the Pupil-teacher ratio(headcount basis) of South Asia in 1988?
Your answer should be very brief. -22.36. What is the difference between the Pupil-teacher ratio(headcount basis) in High income in 1986 and the Pupil-teacher ratio(headcount basis) in Ethiopia in 1988?
Your answer should be very brief. -31.22. What is the difference between the Pupil-teacher ratio(headcount basis) of Latin America(all income levels) in 1986 and the Pupil-teacher ratio(headcount basis) of South Asia in 1988?
Keep it short and to the point. -12.26. What is the difference between the Pupil-teacher ratio(headcount basis) of Latin America(all income levels) in 1986 and the Pupil-teacher ratio(headcount basis) of Ethiopia in 1988?
Your response must be concise. -21.12. What is the difference between the Pupil-teacher ratio(headcount basis) of South Asia in 1986 and the Pupil-teacher ratio(headcount basis) of Ethiopia in 1988?
Keep it short and to the point. -9.06. What is the difference between the Pupil-teacher ratio(headcount basis) of High income in 1987 and the Pupil-teacher ratio(headcount basis) of Latin America(all income levels) in 1988?
Offer a terse response. -9.46. What is the difference between the Pupil-teacher ratio(headcount basis) in High income in 1987 and the Pupil-teacher ratio(headcount basis) in South Asia in 1988?
Offer a very short reply. -22.38. What is the difference between the Pupil-teacher ratio(headcount basis) of High income in 1987 and the Pupil-teacher ratio(headcount basis) of Ethiopia in 1988?
Your answer should be very brief. -31.24. What is the difference between the Pupil-teacher ratio(headcount basis) in Latin America(all income levels) in 1987 and the Pupil-teacher ratio(headcount basis) in South Asia in 1988?
Give a very brief answer. -12.57. What is the difference between the Pupil-teacher ratio(headcount basis) of Latin America(all income levels) in 1987 and the Pupil-teacher ratio(headcount basis) of Ethiopia in 1988?
Your answer should be compact. -21.43. What is the difference between the Pupil-teacher ratio(headcount basis) in South Asia in 1987 and the Pupil-teacher ratio(headcount basis) in Ethiopia in 1988?
Offer a terse response. -9.24. What is the average Pupil-teacher ratio(headcount basis) of High income per year?
Ensure brevity in your answer.  18.43. What is the average Pupil-teacher ratio(headcount basis) of Latin America(all income levels) per year?
Keep it short and to the point. 28.88. What is the average Pupil-teacher ratio(headcount basis) in South Asia per year?
Your response must be concise. 40.97. What is the average Pupil-teacher ratio(headcount basis) in Ethiopia per year?
Keep it short and to the point. 54.41. In the year 1981, what is the difference between the Pupil-teacher ratio(headcount basis) in High income and Pupil-teacher ratio(headcount basis) in Latin America(all income levels)?
Your response must be concise. -11.26. In the year 1981, what is the difference between the Pupil-teacher ratio(headcount basis) in High income and Pupil-teacher ratio(headcount basis) in South Asia?
Make the answer very short. -23.41. In the year 1981, what is the difference between the Pupil-teacher ratio(headcount basis) in High income and Pupil-teacher ratio(headcount basis) in Ethiopia?
Provide a short and direct response. -45.04. In the year 1981, what is the difference between the Pupil-teacher ratio(headcount basis) in Latin America(all income levels) and Pupil-teacher ratio(headcount basis) in South Asia?
Offer a terse response. -12.15. In the year 1981, what is the difference between the Pupil-teacher ratio(headcount basis) of Latin America(all income levels) and Pupil-teacher ratio(headcount basis) of Ethiopia?
Ensure brevity in your answer.  -33.79. In the year 1981, what is the difference between the Pupil-teacher ratio(headcount basis) of South Asia and Pupil-teacher ratio(headcount basis) of Ethiopia?
Offer a very short reply. -21.64. In the year 1982, what is the difference between the Pupil-teacher ratio(headcount basis) of High income and Pupil-teacher ratio(headcount basis) of Latin America(all income levels)?
Provide a succinct answer. -10.96. In the year 1982, what is the difference between the Pupil-teacher ratio(headcount basis) of High income and Pupil-teacher ratio(headcount basis) of South Asia?
Provide a short and direct response. -23.11. In the year 1982, what is the difference between the Pupil-teacher ratio(headcount basis) in High income and Pupil-teacher ratio(headcount basis) in Ethiopia?
Provide a short and direct response. -43.95. In the year 1982, what is the difference between the Pupil-teacher ratio(headcount basis) of Latin America(all income levels) and Pupil-teacher ratio(headcount basis) of South Asia?
Give a very brief answer. -12.15. In the year 1982, what is the difference between the Pupil-teacher ratio(headcount basis) in Latin America(all income levels) and Pupil-teacher ratio(headcount basis) in Ethiopia?
Offer a very short reply. -33. In the year 1982, what is the difference between the Pupil-teacher ratio(headcount basis) of South Asia and Pupil-teacher ratio(headcount basis) of Ethiopia?
Provide a succinct answer. -20.85. In the year 1983, what is the difference between the Pupil-teacher ratio(headcount basis) in High income and Pupil-teacher ratio(headcount basis) in Latin America(all income levels)?
Keep it short and to the point. -10.73. In the year 1983, what is the difference between the Pupil-teacher ratio(headcount basis) of High income and Pupil-teacher ratio(headcount basis) of South Asia?
Offer a very short reply. -22.69. In the year 1983, what is the difference between the Pupil-teacher ratio(headcount basis) in High income and Pupil-teacher ratio(headcount basis) in Ethiopia?
Offer a terse response. -40.66. In the year 1983, what is the difference between the Pupil-teacher ratio(headcount basis) of Latin America(all income levels) and Pupil-teacher ratio(headcount basis) of South Asia?
Your answer should be very brief. -11.95. In the year 1983, what is the difference between the Pupil-teacher ratio(headcount basis) in Latin America(all income levels) and Pupil-teacher ratio(headcount basis) in Ethiopia?
Provide a succinct answer. -29.93. In the year 1983, what is the difference between the Pupil-teacher ratio(headcount basis) in South Asia and Pupil-teacher ratio(headcount basis) in Ethiopia?
Keep it short and to the point. -17.97. In the year 1984, what is the difference between the Pupil-teacher ratio(headcount basis) of High income and Pupil-teacher ratio(headcount basis) of Latin America(all income levels)?
Offer a terse response. -10.64. In the year 1984, what is the difference between the Pupil-teacher ratio(headcount basis) of High income and Pupil-teacher ratio(headcount basis) of South Asia?
Your response must be concise. -22.27. In the year 1984, what is the difference between the Pupil-teacher ratio(headcount basis) of High income and Pupil-teacher ratio(headcount basis) of Ethiopia?
Ensure brevity in your answer.  -35.09. In the year 1984, what is the difference between the Pupil-teacher ratio(headcount basis) of Latin America(all income levels) and Pupil-teacher ratio(headcount basis) of South Asia?
Offer a very short reply. -11.63. In the year 1984, what is the difference between the Pupil-teacher ratio(headcount basis) of Latin America(all income levels) and Pupil-teacher ratio(headcount basis) of Ethiopia?
Your answer should be compact. -24.45. In the year 1984, what is the difference between the Pupil-teacher ratio(headcount basis) of South Asia and Pupil-teacher ratio(headcount basis) of Ethiopia?
Your answer should be compact. -12.82. In the year 1985, what is the difference between the Pupil-teacher ratio(headcount basis) in High income and Pupil-teacher ratio(headcount basis) in Latin America(all income levels)?
Ensure brevity in your answer.  -10.53. In the year 1985, what is the difference between the Pupil-teacher ratio(headcount basis) of High income and Pupil-teacher ratio(headcount basis) of South Asia?
Your response must be concise. -22.2. In the year 1985, what is the difference between the Pupil-teacher ratio(headcount basis) of High income and Pupil-teacher ratio(headcount basis) of Ethiopia?
Offer a very short reply. -31.65. In the year 1985, what is the difference between the Pupil-teacher ratio(headcount basis) of Latin America(all income levels) and Pupil-teacher ratio(headcount basis) of South Asia?
Keep it short and to the point. -11.67. In the year 1985, what is the difference between the Pupil-teacher ratio(headcount basis) in Latin America(all income levels) and Pupil-teacher ratio(headcount basis) in Ethiopia?
Provide a succinct answer. -21.12. In the year 1985, what is the difference between the Pupil-teacher ratio(headcount basis) in South Asia and Pupil-teacher ratio(headcount basis) in Ethiopia?
Make the answer very short. -9.45. In the year 1986, what is the difference between the Pupil-teacher ratio(headcount basis) of High income and Pupil-teacher ratio(headcount basis) of Latin America(all income levels)?
Offer a very short reply. -10.1. In the year 1986, what is the difference between the Pupil-teacher ratio(headcount basis) in High income and Pupil-teacher ratio(headcount basis) in South Asia?
Keep it short and to the point. -22.16. In the year 1986, what is the difference between the Pupil-teacher ratio(headcount basis) in High income and Pupil-teacher ratio(headcount basis) in Ethiopia?
Make the answer very short. -29.92. In the year 1986, what is the difference between the Pupil-teacher ratio(headcount basis) of Latin America(all income levels) and Pupil-teacher ratio(headcount basis) of South Asia?
Ensure brevity in your answer.  -12.06. In the year 1986, what is the difference between the Pupil-teacher ratio(headcount basis) of Latin America(all income levels) and Pupil-teacher ratio(headcount basis) of Ethiopia?
Give a very brief answer. -19.82. In the year 1986, what is the difference between the Pupil-teacher ratio(headcount basis) in South Asia and Pupil-teacher ratio(headcount basis) in Ethiopia?
Your answer should be compact. -7.76. In the year 1987, what is the difference between the Pupil-teacher ratio(headcount basis) of High income and Pupil-teacher ratio(headcount basis) of Latin America(all income levels)?
Give a very brief answer. -9.81. In the year 1987, what is the difference between the Pupil-teacher ratio(headcount basis) of High income and Pupil-teacher ratio(headcount basis) of South Asia?
Offer a very short reply. -22. In the year 1987, what is the difference between the Pupil-teacher ratio(headcount basis) of High income and Pupil-teacher ratio(headcount basis) of Ethiopia?
Make the answer very short. -30.13. In the year 1987, what is the difference between the Pupil-teacher ratio(headcount basis) of Latin America(all income levels) and Pupil-teacher ratio(headcount basis) of South Asia?
Provide a succinct answer. -12.19. In the year 1987, what is the difference between the Pupil-teacher ratio(headcount basis) of Latin America(all income levels) and Pupil-teacher ratio(headcount basis) of Ethiopia?
Ensure brevity in your answer.  -20.32. In the year 1987, what is the difference between the Pupil-teacher ratio(headcount basis) in South Asia and Pupil-teacher ratio(headcount basis) in Ethiopia?
Your response must be concise. -8.13. In the year 1988, what is the difference between the Pupil-teacher ratio(headcount basis) of High income and Pupil-teacher ratio(headcount basis) of Latin America(all income levels)?
Give a very brief answer. -9.59. In the year 1988, what is the difference between the Pupil-teacher ratio(headcount basis) in High income and Pupil-teacher ratio(headcount basis) in South Asia?
Make the answer very short. -22.51. In the year 1988, what is the difference between the Pupil-teacher ratio(headcount basis) in High income and Pupil-teacher ratio(headcount basis) in Ethiopia?
Provide a short and direct response. -31.37. In the year 1988, what is the difference between the Pupil-teacher ratio(headcount basis) in Latin America(all income levels) and Pupil-teacher ratio(headcount basis) in South Asia?
Your answer should be compact. -12.92. In the year 1988, what is the difference between the Pupil-teacher ratio(headcount basis) in Latin America(all income levels) and Pupil-teacher ratio(headcount basis) in Ethiopia?
Give a very brief answer. -21.78. In the year 1988, what is the difference between the Pupil-teacher ratio(headcount basis) of South Asia and Pupil-teacher ratio(headcount basis) of Ethiopia?
Ensure brevity in your answer.  -8.86. What is the ratio of the Pupil-teacher ratio(headcount basis) of Latin America(all income levels) in 1981 to that in 1982?
Provide a succinct answer. 1.01. What is the ratio of the Pupil-teacher ratio(headcount basis) of South Asia in 1981 to that in 1982?
Give a very brief answer. 1.01. What is the ratio of the Pupil-teacher ratio(headcount basis) in Ethiopia in 1981 to that in 1982?
Offer a terse response. 1.02. What is the ratio of the Pupil-teacher ratio(headcount basis) in High income in 1981 to that in 1983?
Your answer should be compact. 1.01. What is the ratio of the Pupil-teacher ratio(headcount basis) in Latin America(all income levels) in 1981 to that in 1983?
Ensure brevity in your answer.  1.03. What is the ratio of the Pupil-teacher ratio(headcount basis) of South Asia in 1981 to that in 1983?
Keep it short and to the point. 1.02. What is the ratio of the Pupil-teacher ratio(headcount basis) in Ethiopia in 1981 to that in 1983?
Your answer should be very brief. 1.08. What is the ratio of the Pupil-teacher ratio(headcount basis) in High income in 1981 to that in 1984?
Provide a succinct answer. 1.02. What is the ratio of the Pupil-teacher ratio(headcount basis) in Latin America(all income levels) in 1981 to that in 1984?
Offer a terse response. 1.04. What is the ratio of the Pupil-teacher ratio(headcount basis) in South Asia in 1981 to that in 1984?
Your answer should be very brief. 1.04. What is the ratio of the Pupil-teacher ratio(headcount basis) in Ethiopia in 1981 to that in 1984?
Keep it short and to the point. 1.19. What is the ratio of the Pupil-teacher ratio(headcount basis) in High income in 1981 to that in 1985?
Your answer should be compact. 1.03. What is the ratio of the Pupil-teacher ratio(headcount basis) of Latin America(all income levels) in 1981 to that in 1985?
Make the answer very short. 1.05. What is the ratio of the Pupil-teacher ratio(headcount basis) of South Asia in 1981 to that in 1985?
Give a very brief answer. 1.04. What is the ratio of the Pupil-teacher ratio(headcount basis) in Ethiopia in 1981 to that in 1985?
Provide a short and direct response. 1.28. What is the ratio of the Pupil-teacher ratio(headcount basis) in High income in 1981 to that in 1986?
Keep it short and to the point. 1.04. What is the ratio of the Pupil-teacher ratio(headcount basis) of Latin America(all income levels) in 1981 to that in 1986?
Your answer should be very brief. 1.07. What is the ratio of the Pupil-teacher ratio(headcount basis) in South Asia in 1981 to that in 1986?
Keep it short and to the point. 1.05. What is the ratio of the Pupil-teacher ratio(headcount basis) in Ethiopia in 1981 to that in 1986?
Make the answer very short. 1.33. What is the ratio of the Pupil-teacher ratio(headcount basis) of High income in 1981 to that in 1987?
Your answer should be very brief. 1.04. What is the ratio of the Pupil-teacher ratio(headcount basis) of Latin America(all income levels) in 1981 to that in 1987?
Your answer should be very brief. 1.08. What is the ratio of the Pupil-teacher ratio(headcount basis) of South Asia in 1981 to that in 1987?
Keep it short and to the point. 1.05. What is the ratio of the Pupil-teacher ratio(headcount basis) of Ethiopia in 1981 to that in 1987?
Offer a very short reply. 1.32. What is the ratio of the Pupil-teacher ratio(headcount basis) in High income in 1981 to that in 1988?
Give a very brief answer. 1.05. What is the ratio of the Pupil-teacher ratio(headcount basis) in Latin America(all income levels) in 1981 to that in 1988?
Provide a succinct answer. 1.09. What is the ratio of the Pupil-teacher ratio(headcount basis) in South Asia in 1981 to that in 1988?
Give a very brief answer. 1.04. What is the ratio of the Pupil-teacher ratio(headcount basis) of Ethiopia in 1981 to that in 1988?
Keep it short and to the point. 1.29. What is the ratio of the Pupil-teacher ratio(headcount basis) in High income in 1982 to that in 1983?
Keep it short and to the point. 1.01. What is the ratio of the Pupil-teacher ratio(headcount basis) of Latin America(all income levels) in 1982 to that in 1983?
Provide a short and direct response. 1.01. What is the ratio of the Pupil-teacher ratio(headcount basis) in South Asia in 1982 to that in 1983?
Ensure brevity in your answer.  1.01. What is the ratio of the Pupil-teacher ratio(headcount basis) of Ethiopia in 1982 to that in 1983?
Offer a very short reply. 1.06. What is the ratio of the Pupil-teacher ratio(headcount basis) of Latin America(all income levels) in 1982 to that in 1984?
Offer a terse response. 1.02. What is the ratio of the Pupil-teacher ratio(headcount basis) in South Asia in 1982 to that in 1984?
Make the answer very short. 1.03. What is the ratio of the Pupil-teacher ratio(headcount basis) of Ethiopia in 1982 to that in 1984?
Offer a terse response. 1.17. What is the ratio of the Pupil-teacher ratio(headcount basis) of High income in 1982 to that in 1985?
Offer a very short reply. 1.02. What is the ratio of the Pupil-teacher ratio(headcount basis) in Latin America(all income levels) in 1982 to that in 1985?
Offer a terse response. 1.03. What is the ratio of the Pupil-teacher ratio(headcount basis) in South Asia in 1982 to that in 1985?
Offer a very short reply. 1.03. What is the ratio of the Pupil-teacher ratio(headcount basis) of Ethiopia in 1982 to that in 1985?
Offer a terse response. 1.26. What is the ratio of the Pupil-teacher ratio(headcount basis) in Latin America(all income levels) in 1982 to that in 1986?
Provide a short and direct response. 1.05. What is the ratio of the Pupil-teacher ratio(headcount basis) of South Asia in 1982 to that in 1986?
Give a very brief answer. 1.04. What is the ratio of the Pupil-teacher ratio(headcount basis) of Ethiopia in 1982 to that in 1986?
Keep it short and to the point. 1.3. What is the ratio of the Pupil-teacher ratio(headcount basis) in High income in 1982 to that in 1987?
Keep it short and to the point. 1.03. What is the ratio of the Pupil-teacher ratio(headcount basis) in Latin America(all income levels) in 1982 to that in 1987?
Keep it short and to the point. 1.06. What is the ratio of the Pupil-teacher ratio(headcount basis) in South Asia in 1982 to that in 1987?
Your answer should be compact. 1.04. What is the ratio of the Pupil-teacher ratio(headcount basis) of Ethiopia in 1982 to that in 1987?
Keep it short and to the point. 1.3. What is the ratio of the Pupil-teacher ratio(headcount basis) of High income in 1982 to that in 1988?
Keep it short and to the point. 1.04. What is the ratio of the Pupil-teacher ratio(headcount basis) of Latin America(all income levels) in 1982 to that in 1988?
Keep it short and to the point. 1.08. What is the ratio of the Pupil-teacher ratio(headcount basis) of South Asia in 1982 to that in 1988?
Keep it short and to the point. 1.03. What is the ratio of the Pupil-teacher ratio(headcount basis) in Ethiopia in 1982 to that in 1988?
Offer a terse response. 1.27. What is the ratio of the Pupil-teacher ratio(headcount basis) of High income in 1983 to that in 1984?
Your answer should be very brief. 1.01. What is the ratio of the Pupil-teacher ratio(headcount basis) in Latin America(all income levels) in 1983 to that in 1984?
Your answer should be very brief. 1.01. What is the ratio of the Pupil-teacher ratio(headcount basis) in South Asia in 1983 to that in 1984?
Your response must be concise. 1.01. What is the ratio of the Pupil-teacher ratio(headcount basis) of Ethiopia in 1983 to that in 1984?
Give a very brief answer. 1.11. What is the ratio of the Pupil-teacher ratio(headcount basis) in High income in 1983 to that in 1985?
Offer a very short reply. 1.02. What is the ratio of the Pupil-teacher ratio(headcount basis) of Latin America(all income levels) in 1983 to that in 1985?
Make the answer very short. 1.02. What is the ratio of the Pupil-teacher ratio(headcount basis) of South Asia in 1983 to that in 1985?
Your answer should be compact. 1.02. What is the ratio of the Pupil-teacher ratio(headcount basis) in Ethiopia in 1983 to that in 1985?
Give a very brief answer. 1.19. What is the ratio of the Pupil-teacher ratio(headcount basis) of High income in 1983 to that in 1986?
Keep it short and to the point. 1.03. What is the ratio of the Pupil-teacher ratio(headcount basis) of Latin America(all income levels) in 1983 to that in 1986?
Provide a succinct answer. 1.04. What is the ratio of the Pupil-teacher ratio(headcount basis) of South Asia in 1983 to that in 1986?
Keep it short and to the point. 1.02. What is the ratio of the Pupil-teacher ratio(headcount basis) in Ethiopia in 1983 to that in 1986?
Keep it short and to the point. 1.23. What is the ratio of the Pupil-teacher ratio(headcount basis) in High income in 1983 to that in 1987?
Ensure brevity in your answer.  1.03. What is the ratio of the Pupil-teacher ratio(headcount basis) in Latin America(all income levels) in 1983 to that in 1987?
Your answer should be very brief. 1.05. What is the ratio of the Pupil-teacher ratio(headcount basis) of South Asia in 1983 to that in 1987?
Make the answer very short. 1.03. What is the ratio of the Pupil-teacher ratio(headcount basis) in Ethiopia in 1983 to that in 1987?
Ensure brevity in your answer.  1.23. What is the ratio of the Pupil-teacher ratio(headcount basis) in High income in 1983 to that in 1988?
Your response must be concise. 1.03. What is the ratio of the Pupil-teacher ratio(headcount basis) in Latin America(all income levels) in 1983 to that in 1988?
Provide a succinct answer. 1.06. What is the ratio of the Pupil-teacher ratio(headcount basis) of South Asia in 1983 to that in 1988?
Offer a very short reply. 1.02. What is the ratio of the Pupil-teacher ratio(headcount basis) of Ethiopia in 1983 to that in 1988?
Give a very brief answer. 1.2. What is the ratio of the Pupil-teacher ratio(headcount basis) of High income in 1984 to that in 1985?
Offer a very short reply. 1.01. What is the ratio of the Pupil-teacher ratio(headcount basis) of Latin America(all income levels) in 1984 to that in 1985?
Provide a short and direct response. 1.01. What is the ratio of the Pupil-teacher ratio(headcount basis) in South Asia in 1984 to that in 1985?
Keep it short and to the point. 1.01. What is the ratio of the Pupil-teacher ratio(headcount basis) of Ethiopia in 1984 to that in 1985?
Your response must be concise. 1.07. What is the ratio of the Pupil-teacher ratio(headcount basis) of South Asia in 1984 to that in 1986?
Ensure brevity in your answer.  1.01. What is the ratio of the Pupil-teacher ratio(headcount basis) in Ethiopia in 1984 to that in 1986?
Provide a short and direct response. 1.11. What is the ratio of the Pupil-teacher ratio(headcount basis) of High income in 1984 to that in 1987?
Make the answer very short. 1.02. What is the ratio of the Pupil-teacher ratio(headcount basis) in Latin America(all income levels) in 1984 to that in 1987?
Keep it short and to the point. 1.04. What is the ratio of the Pupil-teacher ratio(headcount basis) in South Asia in 1984 to that in 1987?
Give a very brief answer. 1.01. What is the ratio of the Pupil-teacher ratio(headcount basis) in Ethiopia in 1984 to that in 1987?
Your response must be concise. 1.11. What is the ratio of the Pupil-teacher ratio(headcount basis) of High income in 1984 to that in 1988?
Offer a very short reply. 1.03. What is the ratio of the Pupil-teacher ratio(headcount basis) in Latin America(all income levels) in 1984 to that in 1988?
Provide a succinct answer. 1.05. What is the ratio of the Pupil-teacher ratio(headcount basis) of South Asia in 1984 to that in 1988?
Make the answer very short. 1.01. What is the ratio of the Pupil-teacher ratio(headcount basis) in Ethiopia in 1984 to that in 1988?
Offer a very short reply. 1.08. What is the ratio of the Pupil-teacher ratio(headcount basis) in High income in 1985 to that in 1986?
Provide a succinct answer. 1.01. What is the ratio of the Pupil-teacher ratio(headcount basis) of Latin America(all income levels) in 1985 to that in 1986?
Offer a very short reply. 1.02. What is the ratio of the Pupil-teacher ratio(headcount basis) in Ethiopia in 1985 to that in 1986?
Provide a short and direct response. 1.04. What is the ratio of the Pupil-teacher ratio(headcount basis) in High income in 1985 to that in 1987?
Your answer should be very brief. 1.01. What is the ratio of the Pupil-teacher ratio(headcount basis) in Latin America(all income levels) in 1985 to that in 1987?
Give a very brief answer. 1.03. What is the ratio of the Pupil-teacher ratio(headcount basis) in South Asia in 1985 to that in 1987?
Provide a short and direct response. 1.01. What is the ratio of the Pupil-teacher ratio(headcount basis) in Ethiopia in 1985 to that in 1987?
Keep it short and to the point. 1.03. What is the ratio of the Pupil-teacher ratio(headcount basis) of High income in 1985 to that in 1988?
Your response must be concise. 1.02. What is the ratio of the Pupil-teacher ratio(headcount basis) of Latin America(all income levels) in 1985 to that in 1988?
Provide a succinct answer. 1.05. What is the ratio of the Pupil-teacher ratio(headcount basis) in Ethiopia in 1985 to that in 1988?
Provide a short and direct response. 1.01. What is the ratio of the Pupil-teacher ratio(headcount basis) in Latin America(all income levels) in 1986 to that in 1987?
Keep it short and to the point. 1.01. What is the ratio of the Pupil-teacher ratio(headcount basis) of High income in 1986 to that in 1988?
Your answer should be compact. 1.01. What is the ratio of the Pupil-teacher ratio(headcount basis) of Ethiopia in 1986 to that in 1988?
Your answer should be compact. 0.97. What is the ratio of the Pupil-teacher ratio(headcount basis) in Latin America(all income levels) in 1987 to that in 1988?
Your response must be concise. 1.01. What is the ratio of the Pupil-teacher ratio(headcount basis) of South Asia in 1987 to that in 1988?
Give a very brief answer. 0.99. What is the ratio of the Pupil-teacher ratio(headcount basis) in Ethiopia in 1987 to that in 1988?
Ensure brevity in your answer.  0.98. What is the difference between the highest and the second highest Pupil-teacher ratio(headcount basis) in High income?
Offer a terse response. 0.13. What is the difference between the highest and the second highest Pupil-teacher ratio(headcount basis) in Latin America(all income levels)?
Provide a short and direct response. 0.43. What is the difference between the highest and the second highest Pupil-teacher ratio(headcount basis) of South Asia?
Your response must be concise. 0.43. What is the difference between the highest and the second highest Pupil-teacher ratio(headcount basis) of Ethiopia?
Provide a short and direct response. 1.22. What is the difference between the highest and the lowest Pupil-teacher ratio(headcount basis) in High income?
Offer a terse response. 0.89. What is the difference between the highest and the lowest Pupil-teacher ratio(headcount basis) of Latin America(all income levels)?
Your response must be concise. 2.55. What is the difference between the highest and the lowest Pupil-teacher ratio(headcount basis) in South Asia?
Offer a terse response. 2.16. What is the difference between the highest and the lowest Pupil-teacher ratio(headcount basis) in Ethiopia?
Make the answer very short. 15.85. 